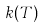<formula> <loc_0><loc_0><loc_500><loc_500>k ( T )</formula> 